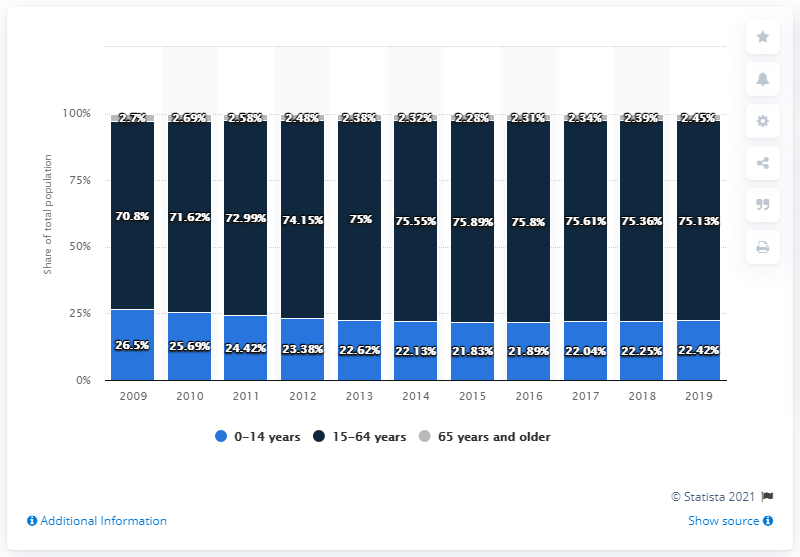Mention a couple of crucial points in this snapshot. The colored bar that always has the least value is gray. The sum of the biggest percent of all age groups across all years is 817.9.. 